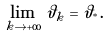Convert formula to latex. <formula><loc_0><loc_0><loc_500><loc_500>\lim _ { k \to + \infty } \vartheta _ { k } = \vartheta _ { ^ { * } } .</formula> 